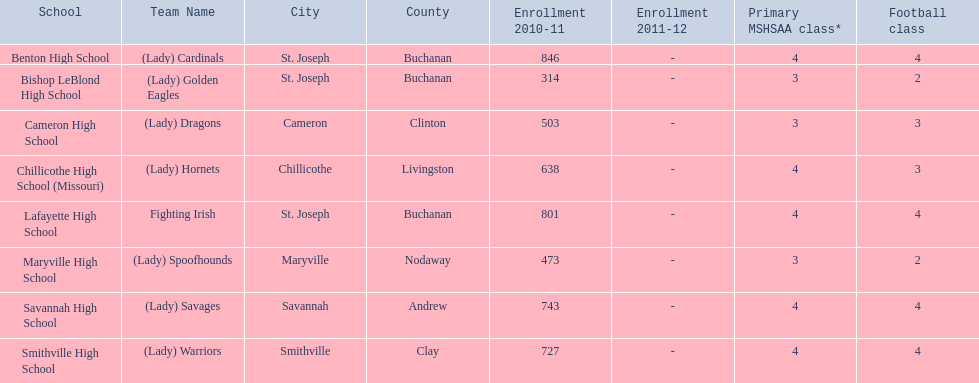What school in midland empire conference has 846 students enrolled? Benton High School. What school has 314 students enrolled? Bishop LeBlond High School. What school had 638 students enrolled? Chillicothe High School (Missouri). 